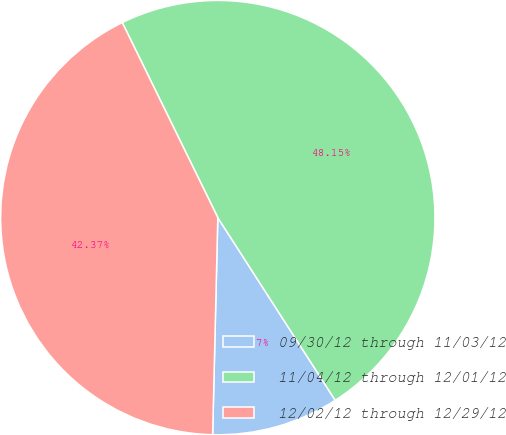Convert chart to OTSL. <chart><loc_0><loc_0><loc_500><loc_500><pie_chart><fcel>09/30/12 through 11/03/12<fcel>11/04/12 through 12/01/12<fcel>12/02/12 through 12/29/12<nl><fcel>9.47%<fcel>48.15%<fcel>42.37%<nl></chart> 